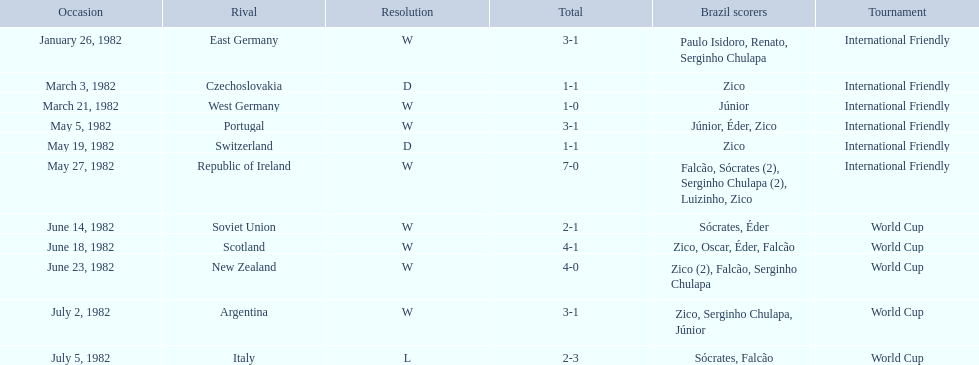What are the dates January 26, 1982, March 3, 1982, March 21, 1982, May 5, 1982, May 19, 1982, May 27, 1982, June 14, 1982, June 18, 1982, June 23, 1982, July 2, 1982, July 5, 1982. Which date is at the top? January 26, 1982. 